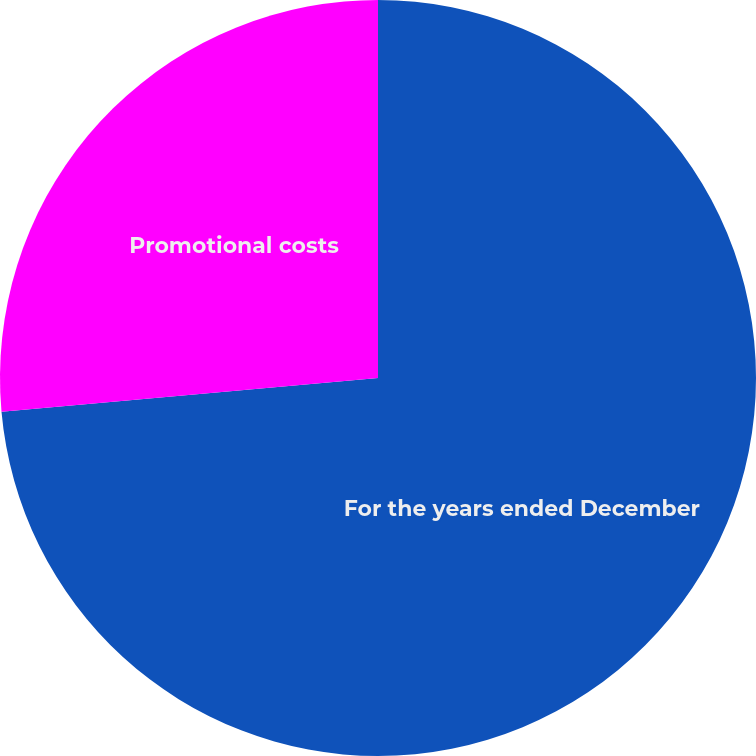Convert chart to OTSL. <chart><loc_0><loc_0><loc_500><loc_500><pie_chart><fcel>For the years ended December<fcel>Promotional costs<nl><fcel>73.58%<fcel>26.42%<nl></chart> 